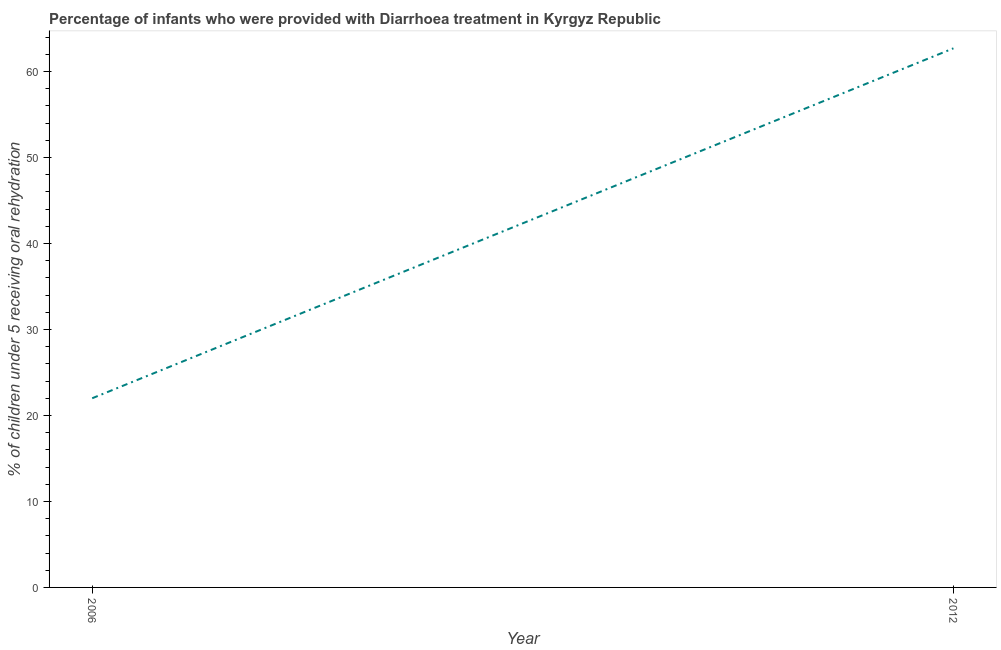What is the percentage of children who were provided with treatment diarrhoea in 2012?
Offer a terse response. 62.7. Across all years, what is the maximum percentage of children who were provided with treatment diarrhoea?
Your response must be concise. 62.7. Across all years, what is the minimum percentage of children who were provided with treatment diarrhoea?
Offer a very short reply. 22. In which year was the percentage of children who were provided with treatment diarrhoea minimum?
Your answer should be very brief. 2006. What is the sum of the percentage of children who were provided with treatment diarrhoea?
Give a very brief answer. 84.7. What is the difference between the percentage of children who were provided with treatment diarrhoea in 2006 and 2012?
Your answer should be very brief. -40.7. What is the average percentage of children who were provided with treatment diarrhoea per year?
Keep it short and to the point. 42.35. What is the median percentage of children who were provided with treatment diarrhoea?
Give a very brief answer. 42.35. Do a majority of the years between 2006 and 2012 (inclusive) have percentage of children who were provided with treatment diarrhoea greater than 44 %?
Ensure brevity in your answer.  No. What is the ratio of the percentage of children who were provided with treatment diarrhoea in 2006 to that in 2012?
Offer a very short reply. 0.35. Is the percentage of children who were provided with treatment diarrhoea in 2006 less than that in 2012?
Your answer should be compact. Yes. How many lines are there?
Offer a terse response. 1. What is the difference between two consecutive major ticks on the Y-axis?
Offer a very short reply. 10. Are the values on the major ticks of Y-axis written in scientific E-notation?
Give a very brief answer. No. Does the graph contain any zero values?
Provide a succinct answer. No. Does the graph contain grids?
Provide a succinct answer. No. What is the title of the graph?
Give a very brief answer. Percentage of infants who were provided with Diarrhoea treatment in Kyrgyz Republic. What is the label or title of the Y-axis?
Your response must be concise. % of children under 5 receiving oral rehydration. What is the % of children under 5 receiving oral rehydration in 2012?
Offer a very short reply. 62.7. What is the difference between the % of children under 5 receiving oral rehydration in 2006 and 2012?
Make the answer very short. -40.7. What is the ratio of the % of children under 5 receiving oral rehydration in 2006 to that in 2012?
Give a very brief answer. 0.35. 